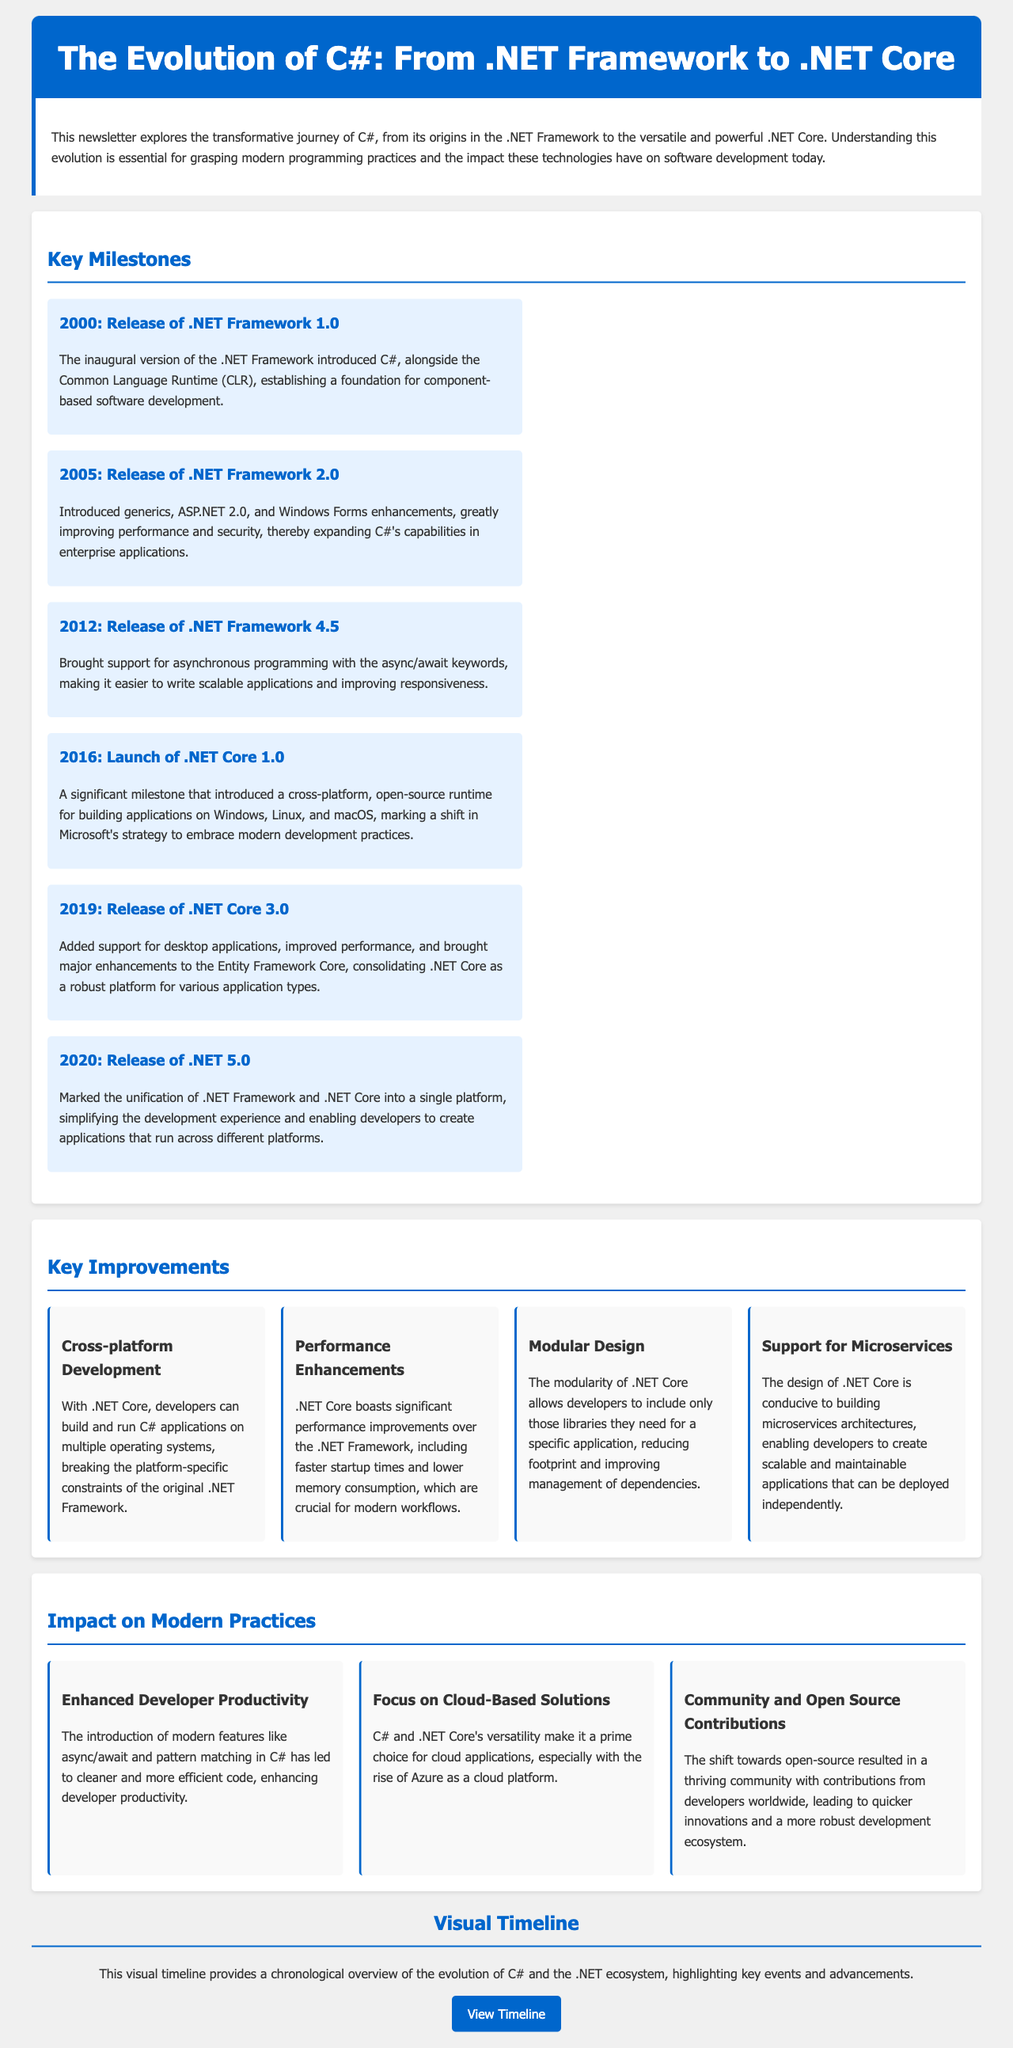What year was .NET Framework 1.0 released? The document states that .NET Framework 1.0 was released in 2000.
Answer: 2000 What new feature was introduced in .NET Framework 2.0? The document mentions that .NET Framework 2.0 introduced generics.
Answer: Generics What was significant about the launch of .NET Core 1.0? The document highlights that it introduced a cross-platform, open-source runtime for building applications, marking a shift in Microsoft's strategy.
Answer: Cross-platform, open-source runtime How many key milestones are listed in the document? The document enumerates six key milestones in the evolution of C#.
Answer: Six What impact do modern features like async/await have on development? The document states that these features enhance developer productivity by leading to cleaner and more efficient code.
Answer: Enhanced developer productivity Which version unified .NET Framework and .NET Core? According to the document, this unification occurred with the release of .NET 5.0 in 2020.
Answer: .NET 5.0 How did .NET Core support microservices architecture? The document notes that .NET Core's design is conducive to building microservices architectures.
Answer: Supports microservices architecture What visual element is provided in the document? The document includes a visual timeline that provides a chronological overview of the evolution of C#.
Answer: Visual timeline Which platform is highlighted in relation to cloud-based solutions? The document emphasizes Azure as a prime choice for cloud applications.
Answer: Azure 